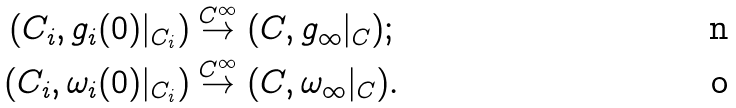<formula> <loc_0><loc_0><loc_500><loc_500>( C _ { i } , g _ { i } ( 0 ) | _ { C _ { i } } ) & \stackrel { C ^ { \infty } } { \to } ( C , g _ { \infty } | _ { C } ) ; \\ ( C _ { i } , \omega _ { i } ( 0 ) | _ { C _ { i } } ) & \stackrel { C ^ { \infty } } { \to } ( C , \omega _ { \infty } | _ { C } ) .</formula> 